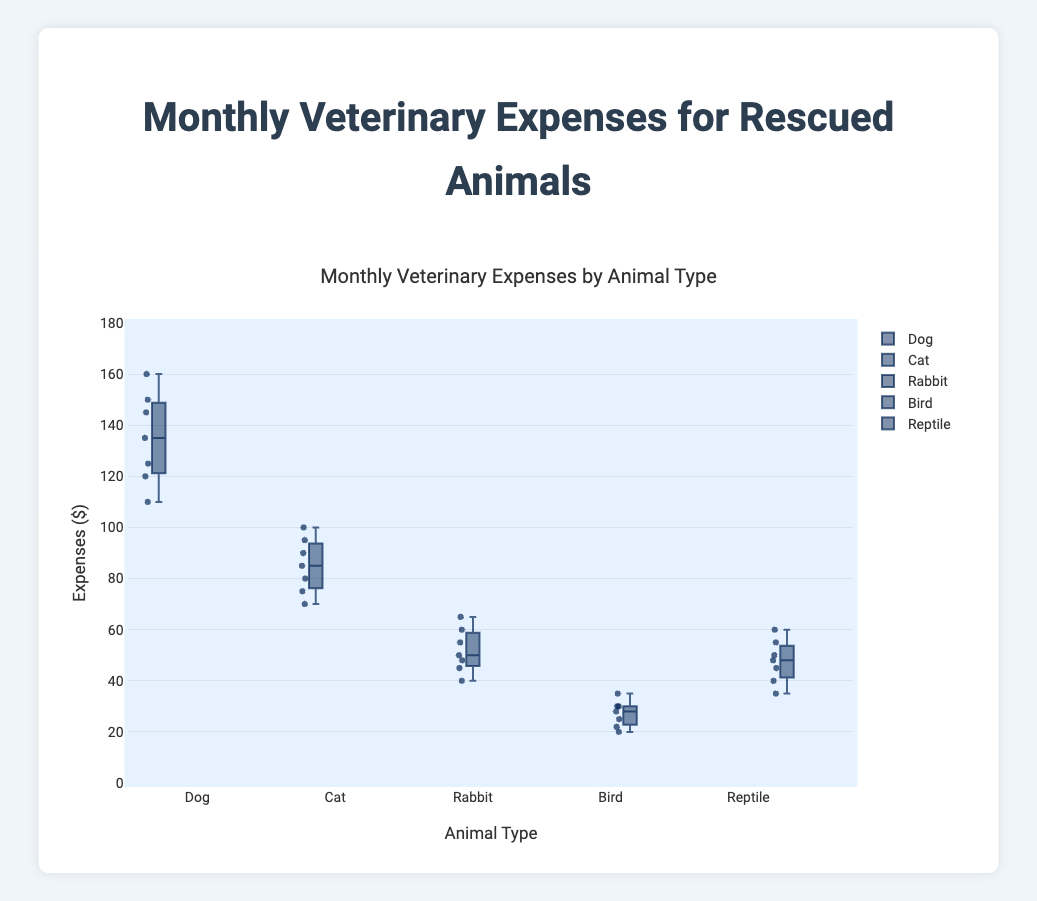What is the title of the plot? The title of the plot is found at the top center of the figure. It provides an overall description of what the plot is about.
Answer: Monthly Veterinary Expenses by Animal Type What is the range of the y-axis? The range of the y-axis is indicated by the numbers on the left side of the plot, running from the lowest to the highest value displayed.
Answer: 0-180 Which animal type has the highest median monthly veterinary expenses? Determine the median (middle value) for all animal types by looking at the line inside each box. The highest median line indicates the animal type with the highest median expenses.
Answer: Dog What is the interquartile range (IQR) for Rabbits? The interquartile range is found by subtracting the lower quartile (bottom of the box) from the upper quartile (top of the box) for Rabbits.
Answer: 15 Which animal type has the smallest range of expenses? The range is the difference between the maximum and minimum expenses (whiskers) for each animal type. The animal type with the smallest difference between the maximum and minimum expenses has the smallest range.
Answer: Bird How do the maximum expenses for Cats compare to those for Dogs? Identify the highest points (whiskers) for both Cats and Dogs. Compare these maximum values to see which is higher.
Answer: Dog's maximum expense is higher What is the median monthly veterinary expense for Reptiles? The median is represented by the line within the box for Reptiles. Identify this value from the plot.
Answer: 48 Compare the lower quartile expenses for Birds and Rabbits. Which has the higher value? The lower quartile is the bottom edge of each box. Compare the lower quartile value of Birds with that of Rabbits.
Answer: Rabbit's lower quartile is higher What is the mean of the monthly expenses for Dogs? To find the mean, sum up all the expenses for Dogs and divide by the number of data points (7). (120 + 135 + 150 + 110 + 160 + 145 + 125) / 7 = 945 / 7
Answer: 135 Identify any outliers in the Reptile expense data if present. Outliers are indicated by points outside the whiskers. Look for any points that are far from the other values and outside the whiskers for Reptiles.
Answer: No outliers 